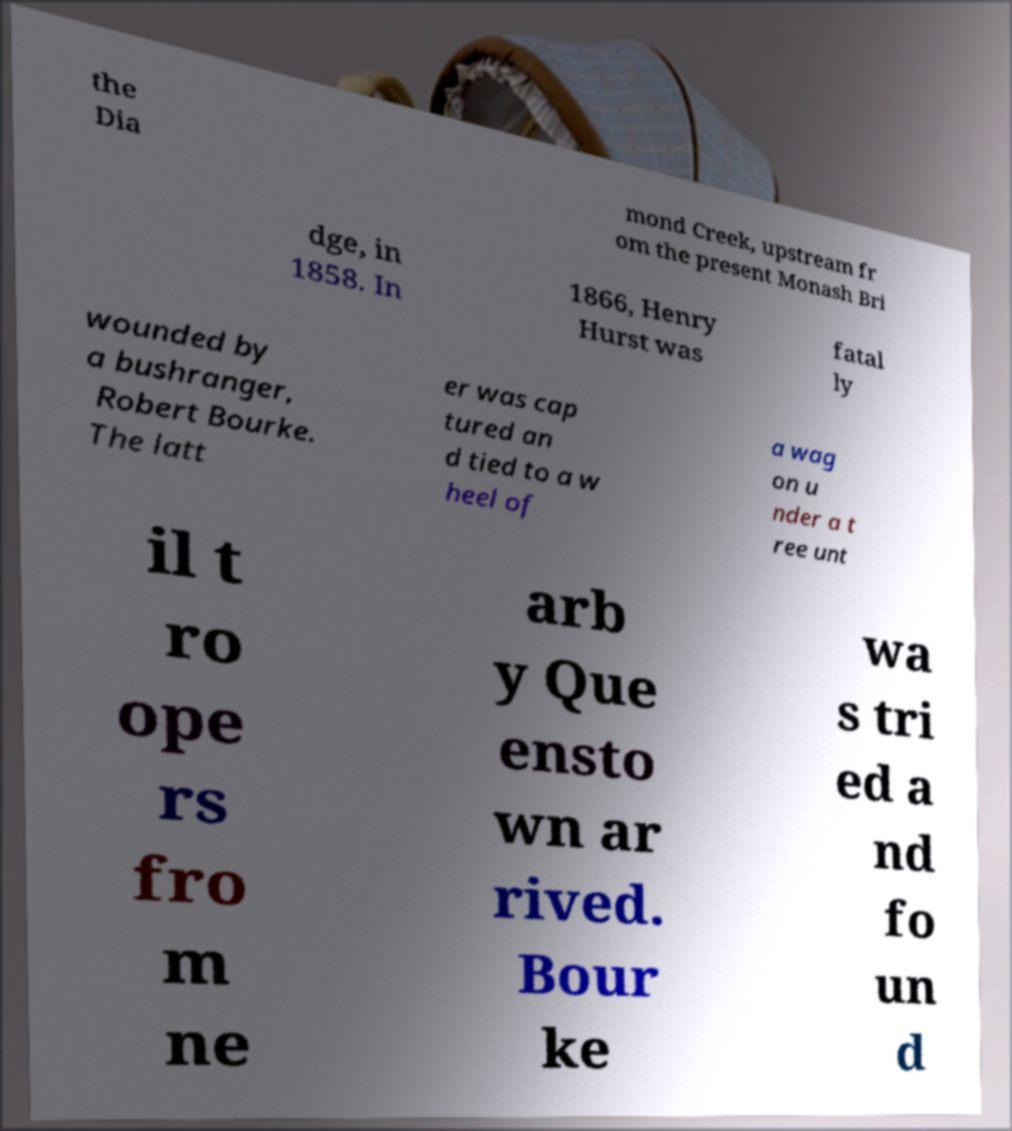For documentation purposes, I need the text within this image transcribed. Could you provide that? the Dia mond Creek, upstream fr om the present Monash Bri dge, in 1858. In 1866, Henry Hurst was fatal ly wounded by a bushranger, Robert Bourke. The latt er was cap tured an d tied to a w heel of a wag on u nder a t ree unt il t ro ope rs fro m ne arb y Que ensto wn ar rived. Bour ke wa s tri ed a nd fo un d 